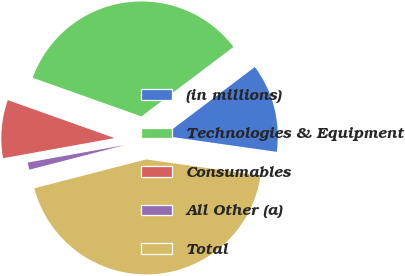Convert chart to OTSL. <chart><loc_0><loc_0><loc_500><loc_500><pie_chart><fcel>(in millions)<fcel>Technologies & Equipment<fcel>Consumables<fcel>All Other (a)<fcel>Total<nl><fcel>12.54%<fcel>34.27%<fcel>8.28%<fcel>1.18%<fcel>43.73%<nl></chart> 